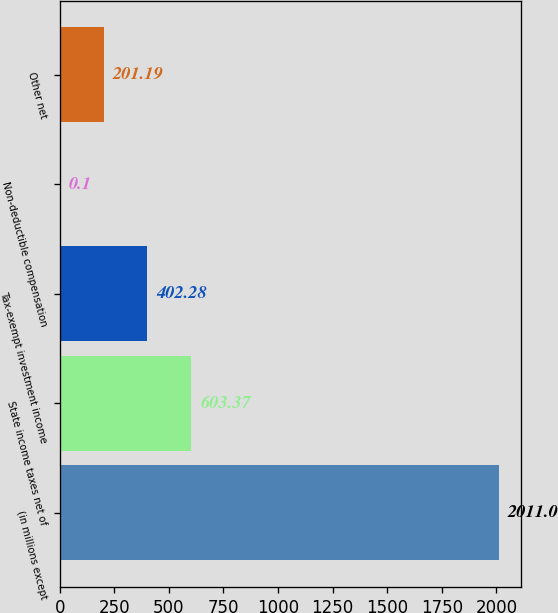Convert chart. <chart><loc_0><loc_0><loc_500><loc_500><bar_chart><fcel>(in millions except<fcel>State income taxes net of<fcel>Tax-exempt investment income<fcel>Non-deductible compensation<fcel>Other net<nl><fcel>2011<fcel>603.37<fcel>402.28<fcel>0.1<fcel>201.19<nl></chart> 